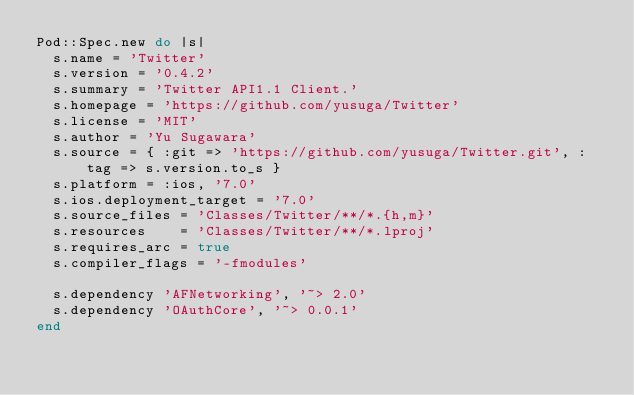Convert code to text. <code><loc_0><loc_0><loc_500><loc_500><_Ruby_>Pod::Spec.new do |s|
  s.name = 'Twitter'
  s.version = '0.4.2'
  s.summary = 'Twitter API1.1 Client.'
  s.homepage = 'https://github.com/yusuga/Twitter'
  s.license = 'MIT'
  s.author = 'Yu Sugawara'
  s.source = { :git => 'https://github.com/yusuga/Twitter.git', :tag => s.version.to_s }
  s.platform = :ios, '7.0'
  s.ios.deployment_target = '7.0'
  s.source_files = 'Classes/Twitter/**/*.{h,m}'
  s.resources    = 'Classes/Twitter/**/*.lproj'
  s.requires_arc = true
  s.compiler_flags = '-fmodules'
  
  s.dependency 'AFNetworking', '~> 2.0'
  s.dependency 'OAuthCore', '~> 0.0.1'
end</code> 